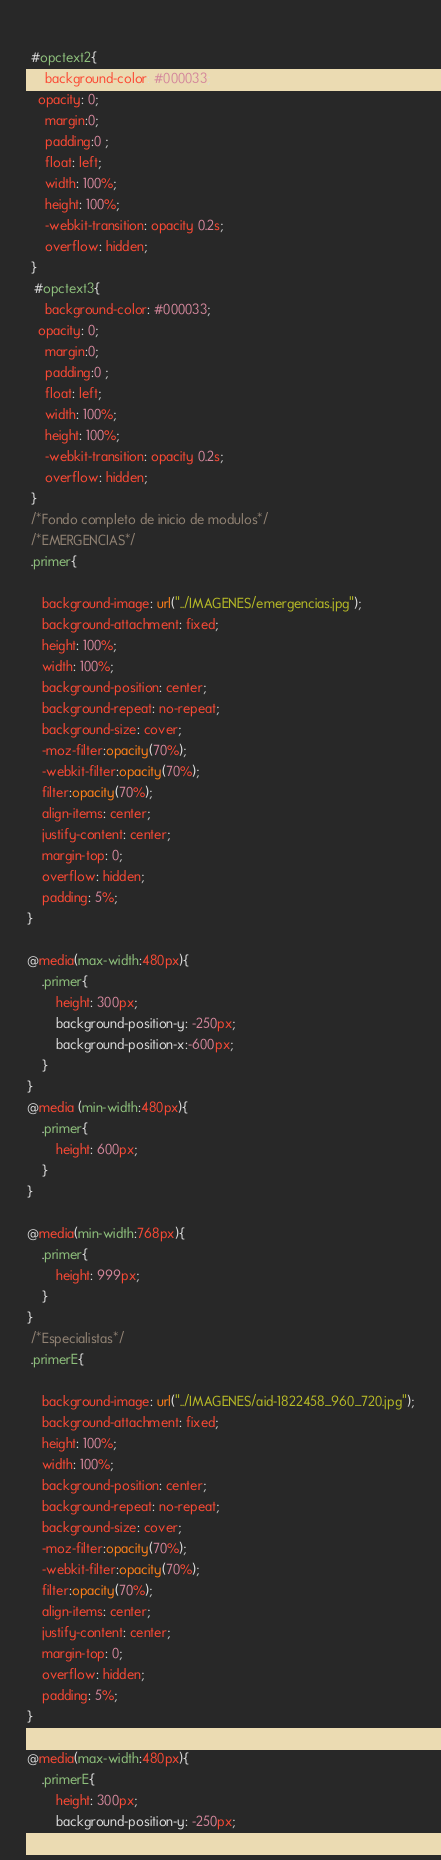Convert code to text. <code><loc_0><loc_0><loc_500><loc_500><_CSS_> 
 #opctext2{
     background-color: #000033;
   opacity: 0;
     margin:0;
     padding:0 ;
     float: left;
     width: 100%;
     height: 100%;
     -webkit-transition: opacity 0.2s;
     overflow: hidden;
 }
  #opctext3{
     background-color: #000033;
   opacity: 0;
     margin:0;
     padding:0 ;
     float: left;
     width: 100%;
     height: 100%;
     -webkit-transition: opacity 0.2s;
     overflow: hidden;
 }
 /*Fondo completo de inicio de modulos*/
 /*EMERGENCIAS*/
 .primer{
    
    background-image: url("../IMAGENES/emergencias.jpg");
    background-attachment: fixed;
    height: 100%;
    width: 100%;
    background-position: center;
    background-repeat: no-repeat;
    background-size: cover;
    -moz-filter:opacity(70%);
    -webkit-filter:opacity(70%);
    filter:opacity(70%);
    align-items: center;
    justify-content: center; 
    margin-top: 0;
    overflow: hidden;
    padding: 5%;
}

@media(max-width:480px){
    .primer{
        height: 300px;
        background-position-y: -250px;
        background-position-x:-600px;
    }
}
@media (min-width:480px){
    .primer{
        height: 600px;
    }
}

@media(min-width:768px){
    .primer{
        height: 999px;
    }
}
 /*Especialistas*/
 .primerE{
    
    background-image: url("../IMAGENES/aid-1822458_960_720.jpg");
    background-attachment: fixed;
    height: 100%;
    width: 100%;
    background-position: center;
    background-repeat: no-repeat;
    background-size: cover;
    -moz-filter:opacity(70%);
    -webkit-filter:opacity(70%);
    filter:opacity(70%);
    align-items: center;
    justify-content: center; 
    margin-top: 0;
    overflow: hidden;
    padding: 5%;
}

@media(max-width:480px){
    .primerE{
        height: 300px;
        background-position-y: -250px;</code> 